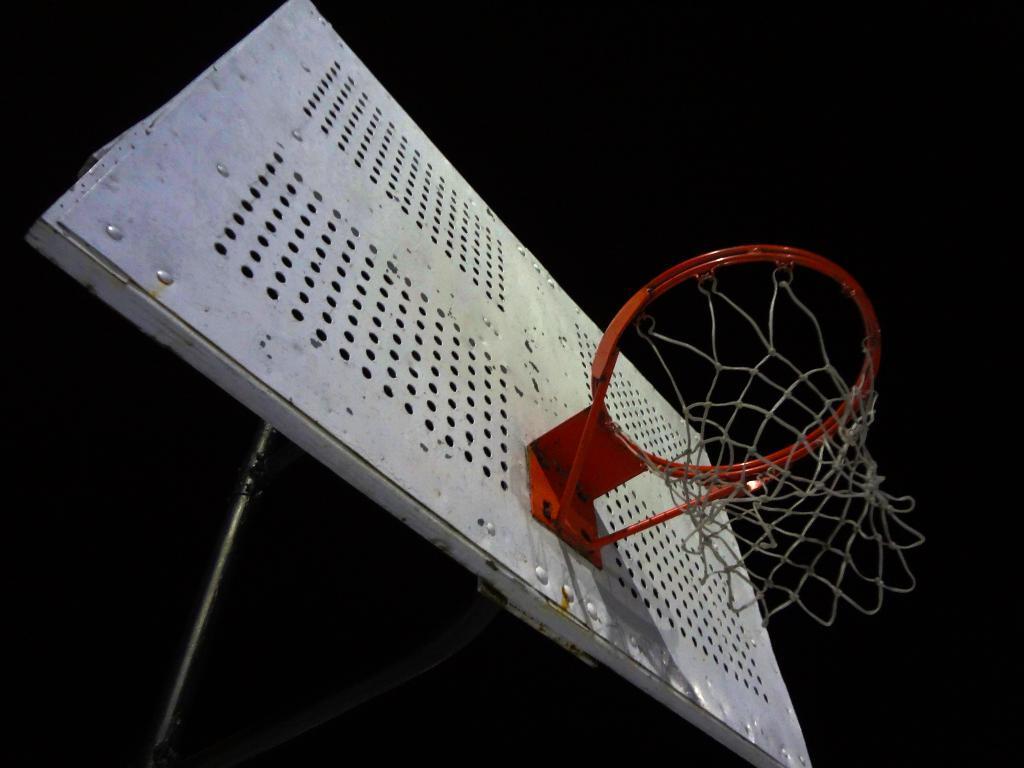Please provide a concise description of this image. In this image, we can see a basketball hoop and rods. In the background, we can see dark. 